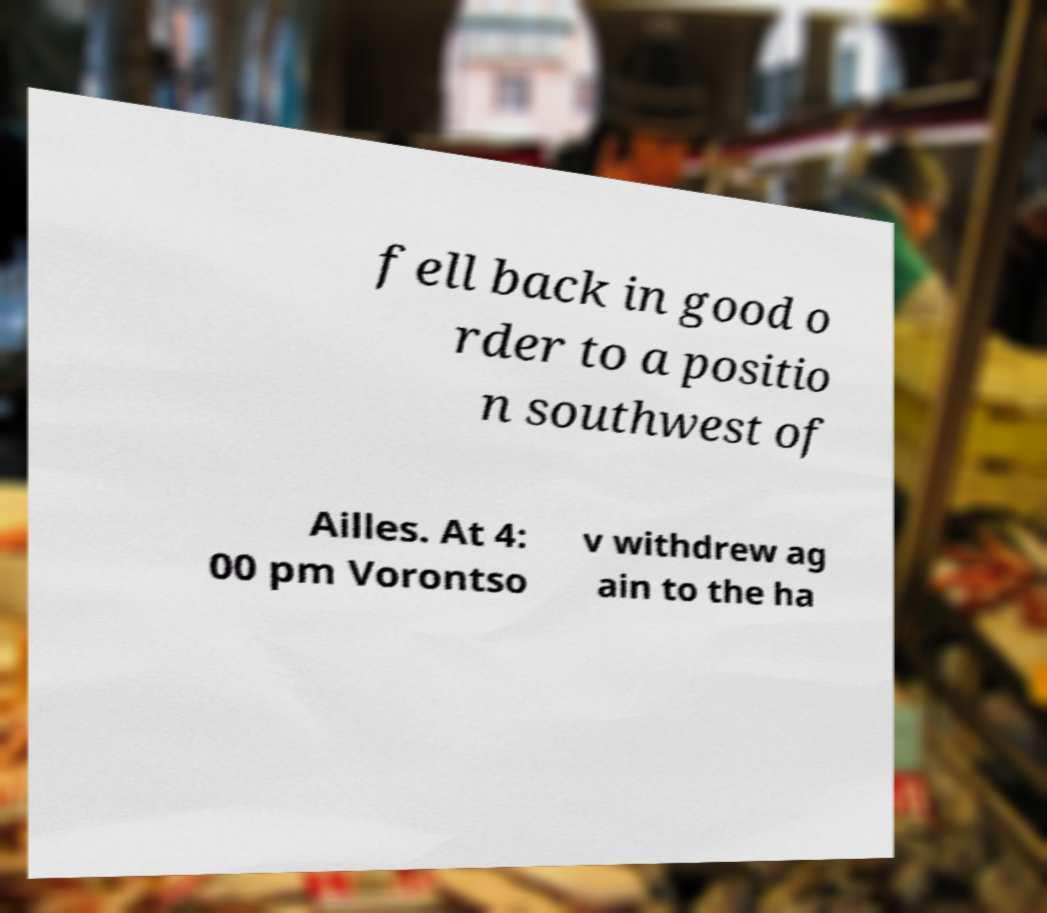Can you read and provide the text displayed in the image?This photo seems to have some interesting text. Can you extract and type it out for me? fell back in good o rder to a positio n southwest of Ailles. At 4: 00 pm Vorontso v withdrew ag ain to the ha 